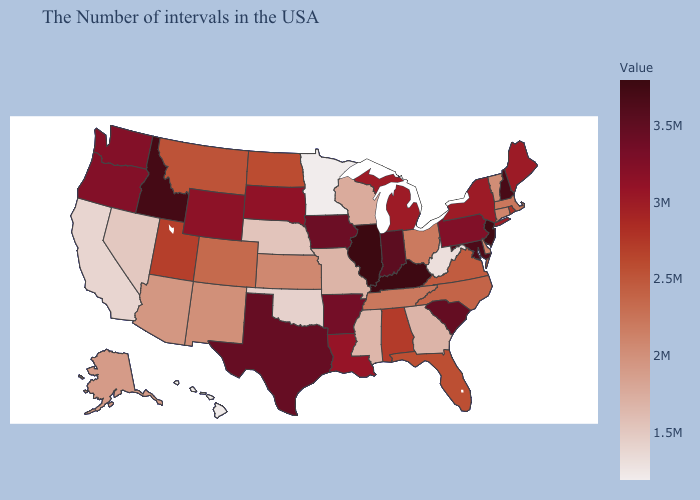Among the states that border Oregon , does California have the highest value?
Keep it brief. No. Which states hav the highest value in the MidWest?
Give a very brief answer. Illinois. Among the states that border Wisconsin , does Illinois have the lowest value?
Answer briefly. No. Among the states that border South Carolina , which have the lowest value?
Write a very short answer. Georgia. Which states have the lowest value in the West?
Quick response, please. Hawaii. Does North Carolina have a higher value than Maryland?
Keep it brief. No. Among the states that border Minnesota , does South Dakota have the lowest value?
Concise answer only. No. 